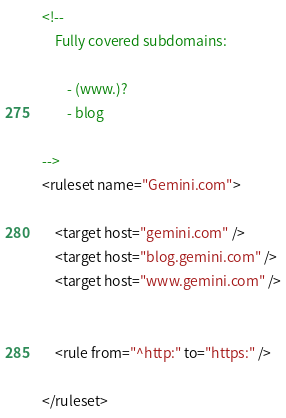Convert code to text. <code><loc_0><loc_0><loc_500><loc_500><_XML_><!--
	Fully covered subdomains:

		- (www.)?
		- blog

-->
<ruleset name="Gemini.com">

	<target host="gemini.com" />
	<target host="blog.gemini.com" />
	<target host="www.gemini.com" />


	<rule from="^http:" to="https:" />

</ruleset>
</code> 